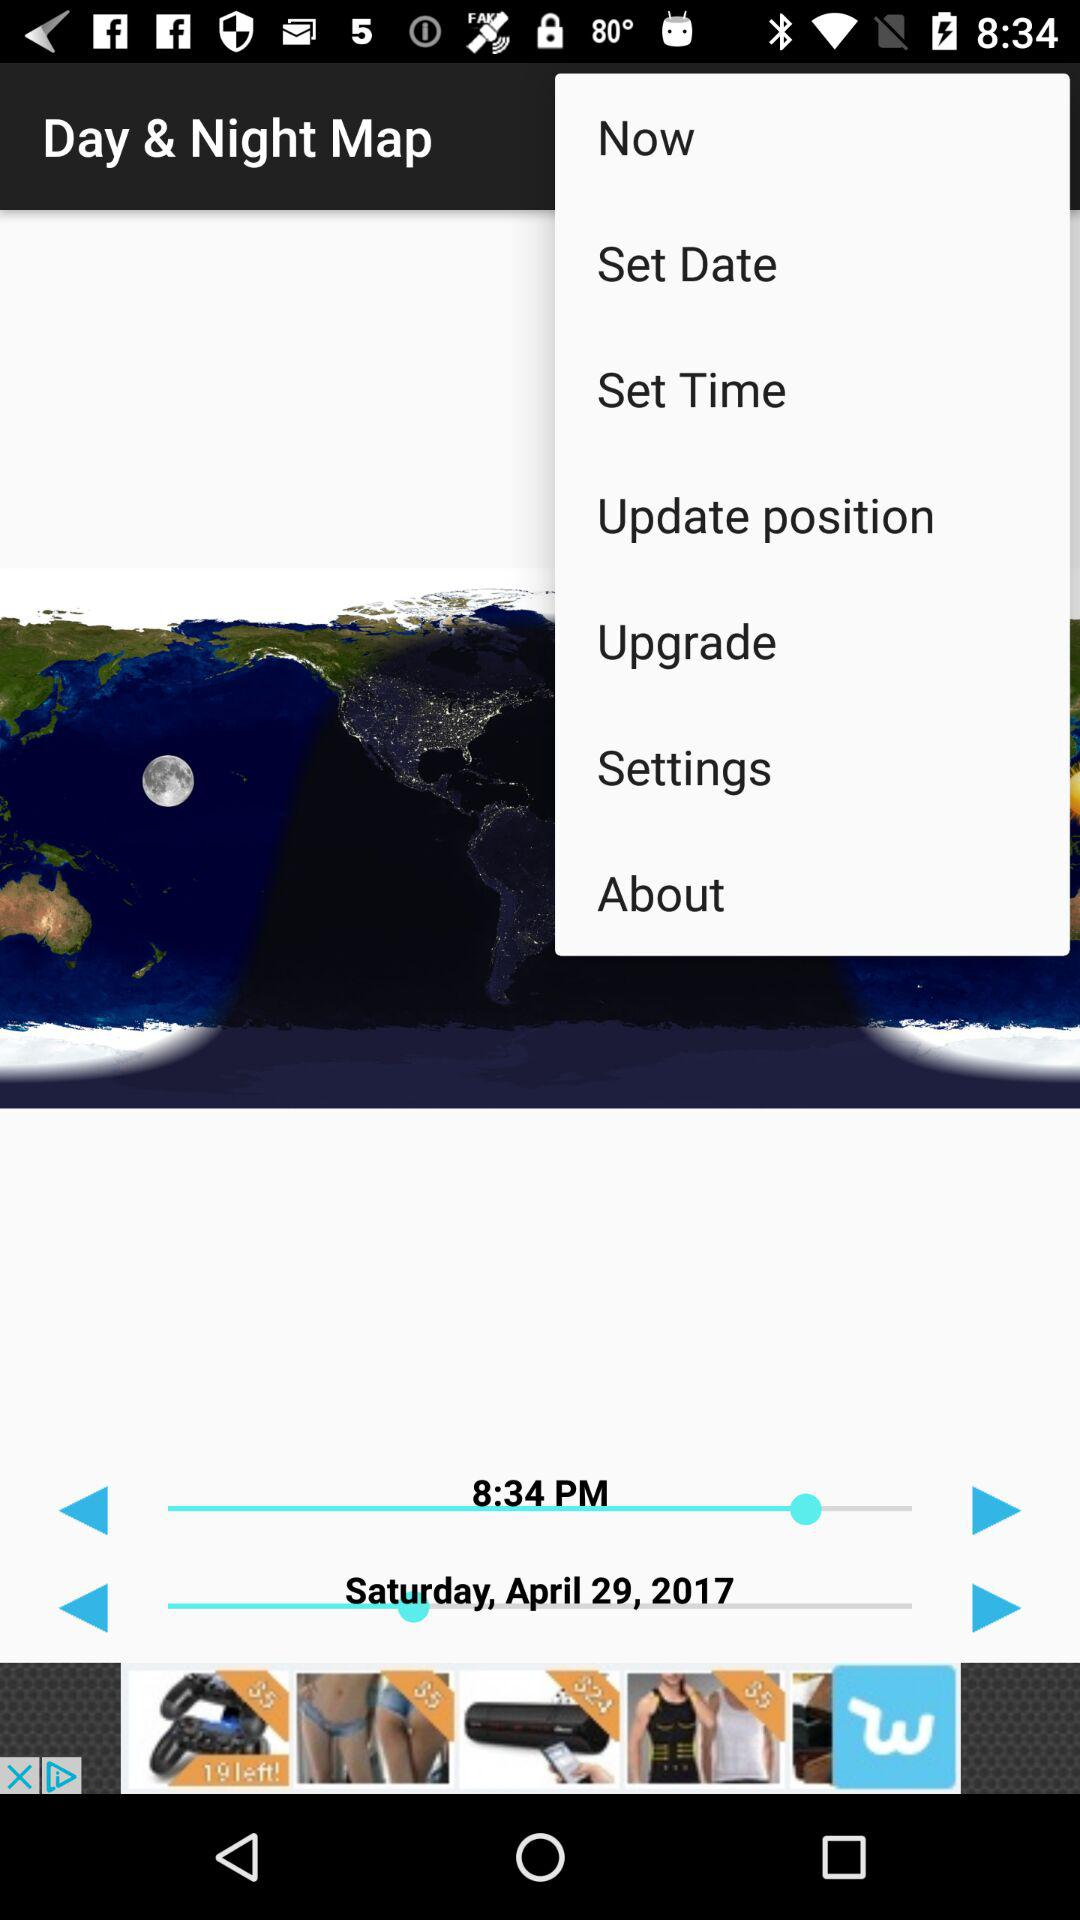What is the date displayed on the screen? The date is Saturday, April 29, 2017. 